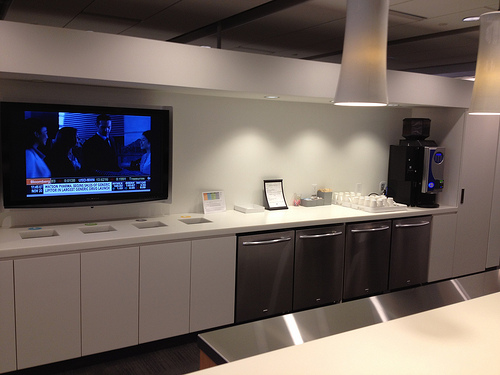Please provide a short description for this region: [0.0, 0.5, 0.91, 0.65]. This region contains a white counter. 